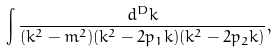<formula> <loc_0><loc_0><loc_500><loc_500>\int \frac { d ^ { D } k } { ( k ^ { 2 } - m ^ { 2 } ) ( k ^ { 2 } - 2 p _ { 1 } k ) ( k ^ { 2 } - 2 p _ { 2 } k ) } ,</formula> 